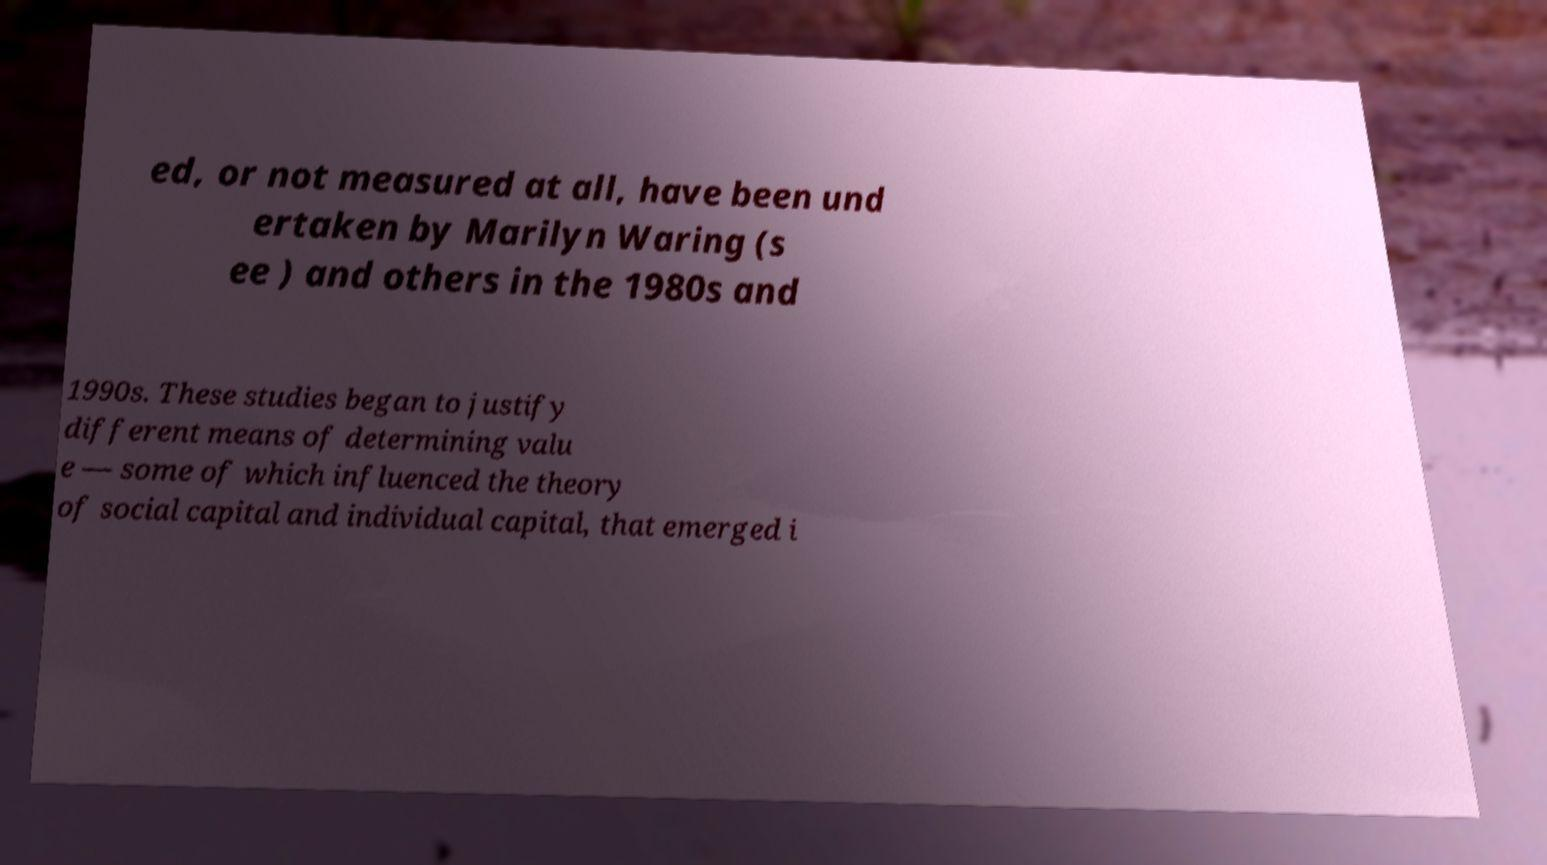I need the written content from this picture converted into text. Can you do that? ed, or not measured at all, have been und ertaken by Marilyn Waring (s ee ) and others in the 1980s and 1990s. These studies began to justify different means of determining valu e — some of which influenced the theory of social capital and individual capital, that emerged i 